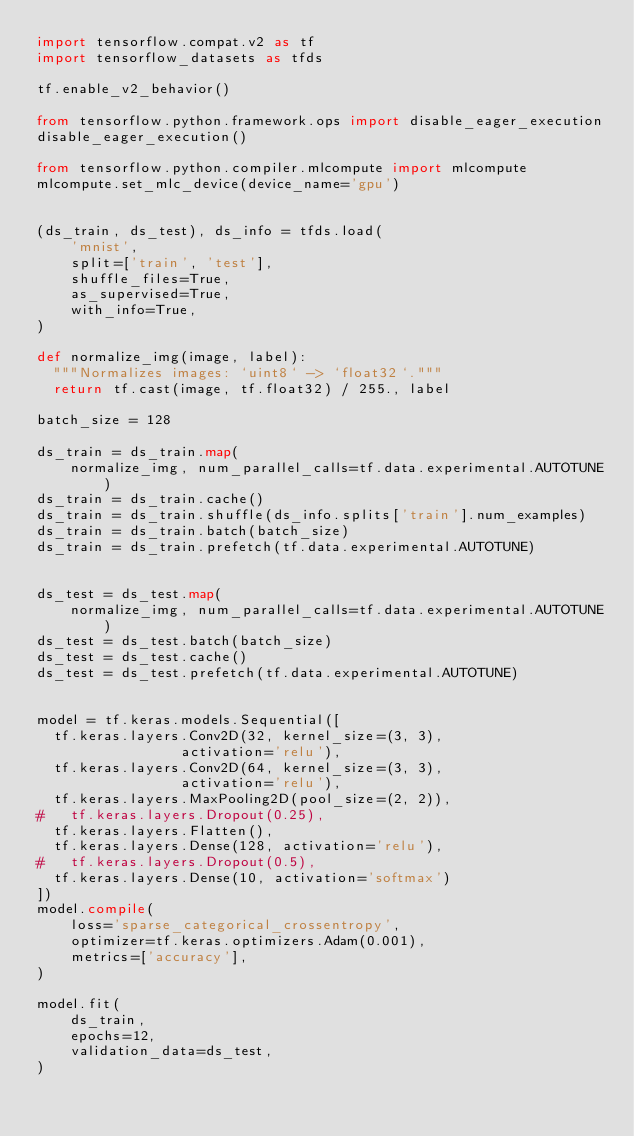Convert code to text. <code><loc_0><loc_0><loc_500><loc_500><_Python_>import tensorflow.compat.v2 as tf
import tensorflow_datasets as tfds

tf.enable_v2_behavior()

from tensorflow.python.framework.ops import disable_eager_execution
disable_eager_execution()

from tensorflow.python.compiler.mlcompute import mlcompute
mlcompute.set_mlc_device(device_name='gpu')


(ds_train, ds_test), ds_info = tfds.load(
    'mnist',
    split=['train', 'test'],
    shuffle_files=True,
    as_supervised=True,
    with_info=True,
)

def normalize_img(image, label):
  """Normalizes images: `uint8` -> `float32`."""
  return tf.cast(image, tf.float32) / 255., label

batch_size = 128

ds_train = ds_train.map(
    normalize_img, num_parallel_calls=tf.data.experimental.AUTOTUNE)
ds_train = ds_train.cache()
ds_train = ds_train.shuffle(ds_info.splits['train'].num_examples)
ds_train = ds_train.batch(batch_size)
ds_train = ds_train.prefetch(tf.data.experimental.AUTOTUNE)


ds_test = ds_test.map(
    normalize_img, num_parallel_calls=tf.data.experimental.AUTOTUNE)
ds_test = ds_test.batch(batch_size)
ds_test = ds_test.cache()
ds_test = ds_test.prefetch(tf.data.experimental.AUTOTUNE)


model = tf.keras.models.Sequential([
  tf.keras.layers.Conv2D(32, kernel_size=(3, 3),
                 activation='relu'),
  tf.keras.layers.Conv2D(64, kernel_size=(3, 3),
                 activation='relu'),
  tf.keras.layers.MaxPooling2D(pool_size=(2, 2)),
#   tf.keras.layers.Dropout(0.25),
  tf.keras.layers.Flatten(),
  tf.keras.layers.Dense(128, activation='relu'),
#   tf.keras.layers.Dropout(0.5),
  tf.keras.layers.Dense(10, activation='softmax')
])
model.compile(
    loss='sparse_categorical_crossentropy',
    optimizer=tf.keras.optimizers.Adam(0.001),
    metrics=['accuracy'],
)

model.fit(
    ds_train,
    epochs=12,
    validation_data=ds_test,
)</code> 